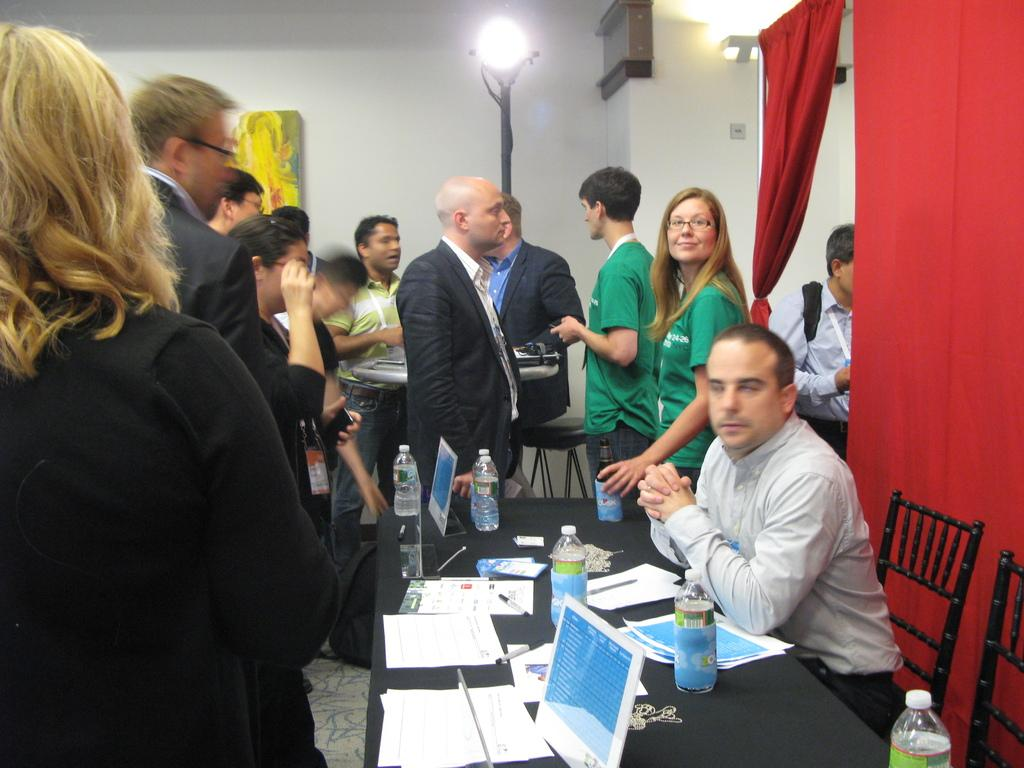What is the person in the image doing? The person is sitting on a chair at a table. What items can be seen on the table? There are water bottles, pens, and papers on the table. Can you describe the background of the image? There are people, a wall, a light, and curtains in the background of the image. What type of basket is being used for comparison in the image? There is no basket present in the image, nor is there any indication of a comparison being made. What is the person drinking in the image? The provided facts do not mention any beverages, including eggnog, in the image. 